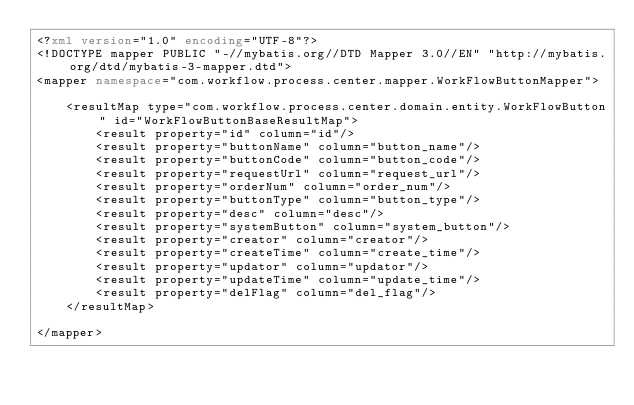Convert code to text. <code><loc_0><loc_0><loc_500><loc_500><_XML_><?xml version="1.0" encoding="UTF-8"?>
<!DOCTYPE mapper PUBLIC "-//mybatis.org//DTD Mapper 3.0//EN" "http://mybatis.org/dtd/mybatis-3-mapper.dtd">
<mapper namespace="com.workflow.process.center.mapper.WorkFlowButtonMapper">

    <resultMap type="com.workflow.process.center.domain.entity.WorkFlowButton" id="WorkFlowButtonBaseResultMap">
        <result property="id" column="id"/>
        <result property="buttonName" column="button_name"/>
        <result property="buttonCode" column="button_code"/>
        <result property="requestUrl" column="request_url"/>
        <result property="orderNum" column="order_num"/>
        <result property="buttonType" column="button_type"/>
        <result property="desc" column="desc"/>
        <result property="systemButton" column="system_button"/>
        <result property="creator" column="creator"/>
        <result property="createTime" column="create_time"/>
        <result property="updator" column="updator"/>
        <result property="updateTime" column="update_time"/>
        <result property="delFlag" column="del_flag"/>
    </resultMap>

</mapper>
</code> 